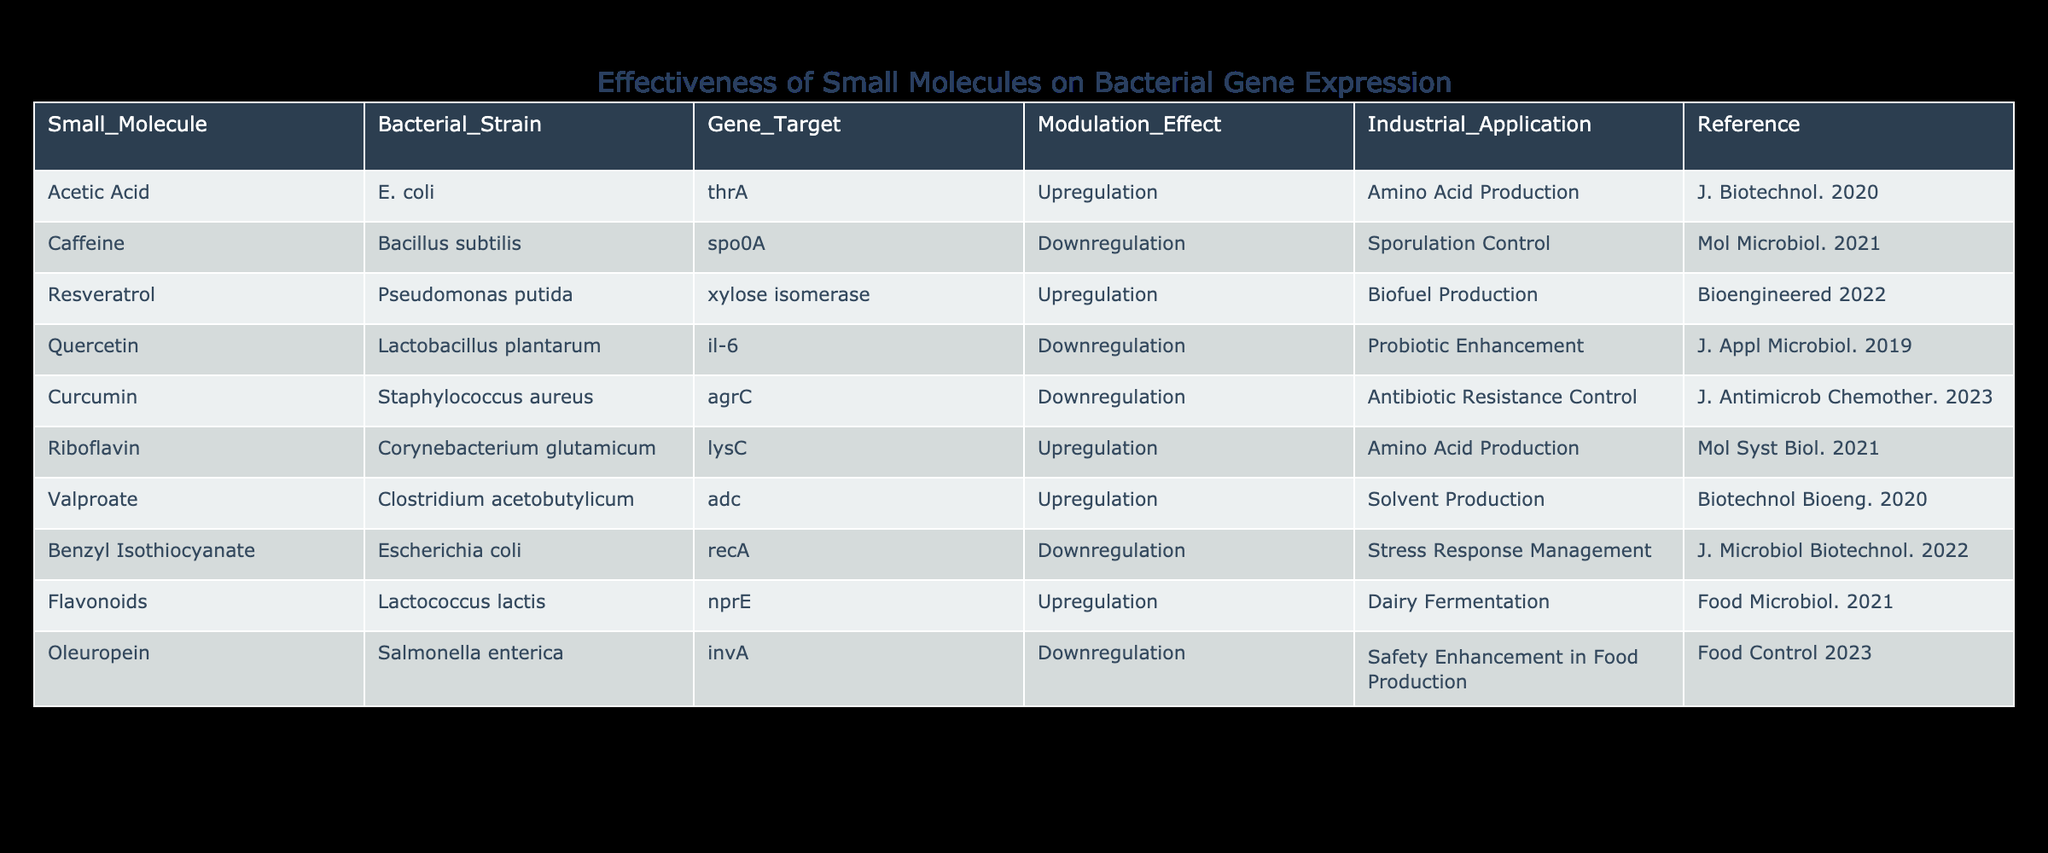What small molecule is associated with upregulation of the gene target thrA? The table shows that acetic acid is linked with upregulation of the gene target thrA in E. coli.
Answer: Acetic Acid How many bacterial strains demonstrate downregulation effects in the table? By examining the table, we see that four bacterial strains (Bacillus subtilis, Lactobacillus plantarum, Staphylococcus aureus, and Salmonella enterica) are associated with downregulation effects.
Answer: 4 Does Quercetin have an industrial application related to probiotic enhancement? The table indicates that Quercetin is indeed associated with probiotic enhancement, confirming that it has this industrial application.
Answer: Yes Which small molecule is involved in the upregulation of a gene target related to biofuel production? Looking at the table, resveratrol is the small molecule associated with the upregulation of xylose isomerase, a gene target linked to biofuel production.
Answer: Resveratrol Among the provided small molecules, which one has a reference published most recently? Upon reviewing the references, it is observed that curcumin from J. Antimicrob Chemother. was published in 2023, making it the most recent.
Answer: Curcumin What is the modulation effect of riboflavin on Corynebacterium glutamicum's gene target? The table specifies that riboflavin leads to upregulation of the gene target lysC in Corynebacterium glutamicum.
Answer: Upregulation If you want to control sporulation in an industrial setting, which small molecule would you consider using? The table shows that caffeine is responsible for downregulation of the gene target spo0A, which is crucial for sporulation control, making it the best choice for this application.
Answer: Caffeine How many different industrial applications are associated with the small molecules listed in the table? The table indicates a total of six distinct industrial applications: amino acid production, sporulation control, biofuel production, probiotic enhancement, antibiotic resistance control, and safety enhancement in food production. Counting each unique application gives us this total.
Answer: 6 Is there a small molecule that regulates the gene target recA? According to the table, benzyl isothiocyanate regulates recA but with a downregulation effect, confirming the presence of such a small molecule.
Answer: Yes 